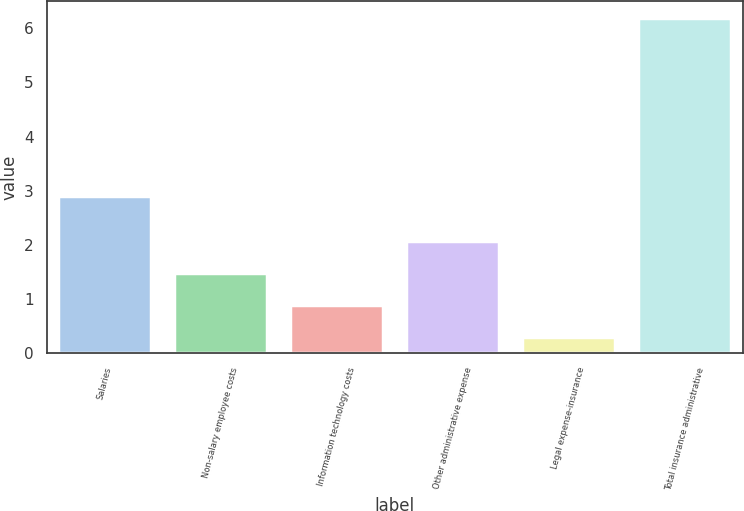Convert chart. <chart><loc_0><loc_0><loc_500><loc_500><bar_chart><fcel>Salaries<fcel>Non-salary employee costs<fcel>Information technology costs<fcel>Other administrative expense<fcel>Legal expense-insurance<fcel>Total insurance administrative<nl><fcel>2.9<fcel>1.48<fcel>0.89<fcel>2.07<fcel>0.3<fcel>6.2<nl></chart> 